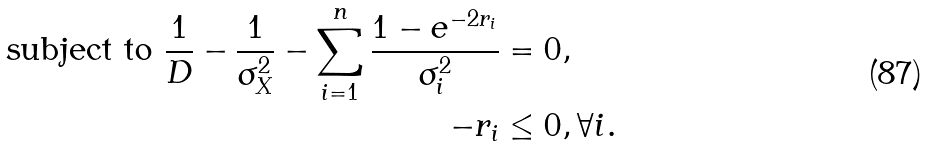<formula> <loc_0><loc_0><loc_500><loc_500>\text {subject to } \frac { 1 } { D } - \frac { 1 } { \sigma ^ { 2 } _ { X } } - \sum _ { i = 1 } ^ { n } \frac { 1 - e ^ { - 2 r _ { i } } } { \sigma ^ { 2 } _ { i } } & = 0 , \\ - r _ { i } & \leq 0 , \forall i .</formula> 